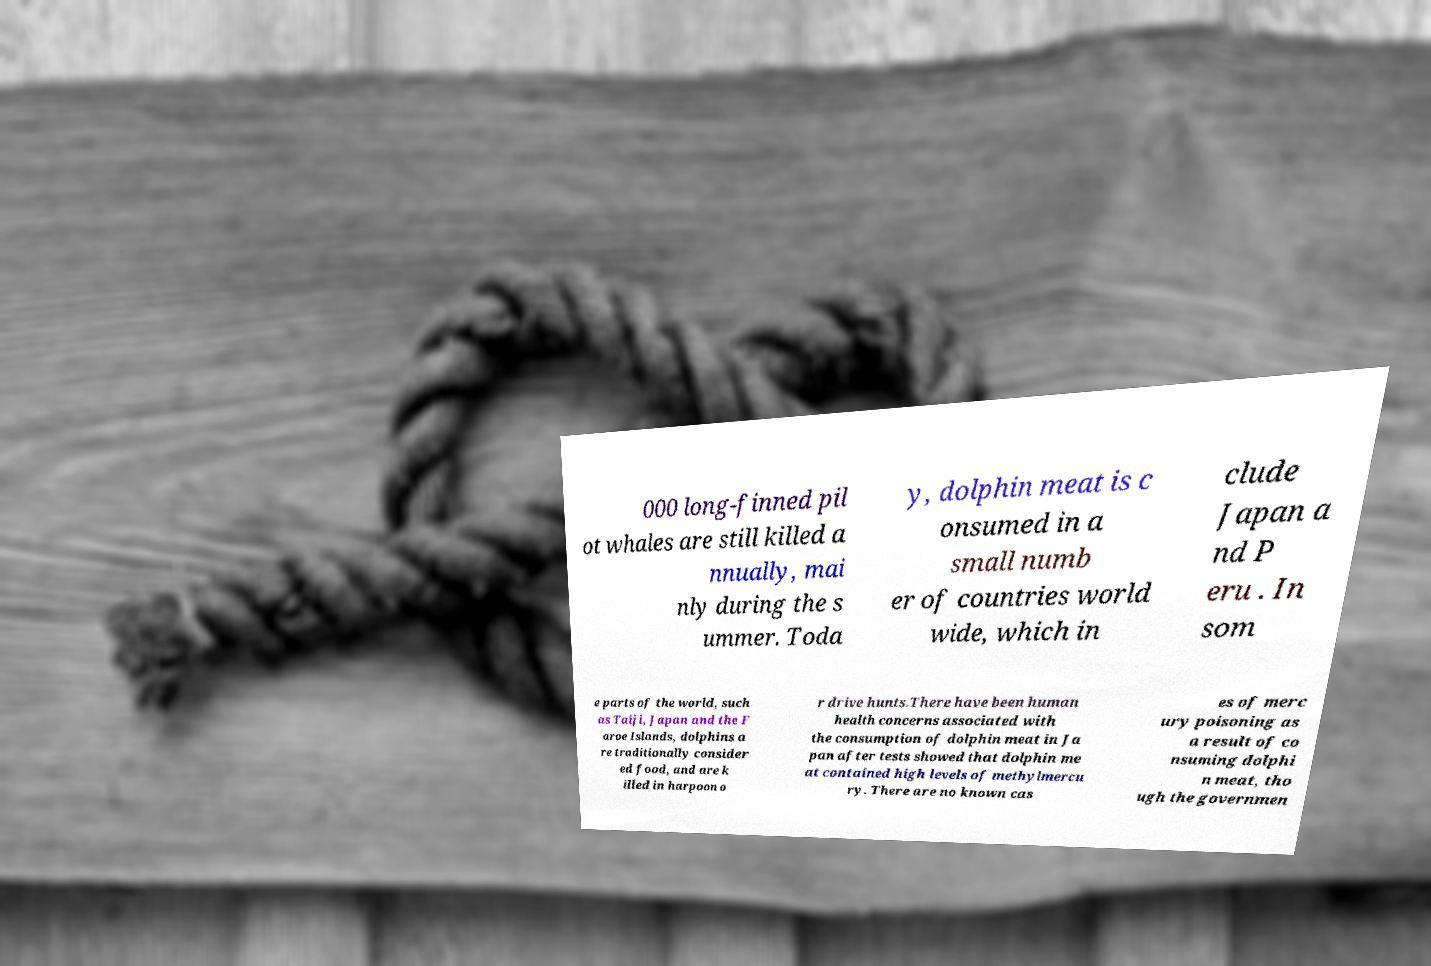There's text embedded in this image that I need extracted. Can you transcribe it verbatim? 000 long-finned pil ot whales are still killed a nnually, mai nly during the s ummer. Toda y, dolphin meat is c onsumed in a small numb er of countries world wide, which in clude Japan a nd P eru . In som e parts of the world, such as Taiji, Japan and the F aroe Islands, dolphins a re traditionally consider ed food, and are k illed in harpoon o r drive hunts.There have been human health concerns associated with the consumption of dolphin meat in Ja pan after tests showed that dolphin me at contained high levels of methylmercu ry. There are no known cas es of merc ury poisoning as a result of co nsuming dolphi n meat, tho ugh the governmen 